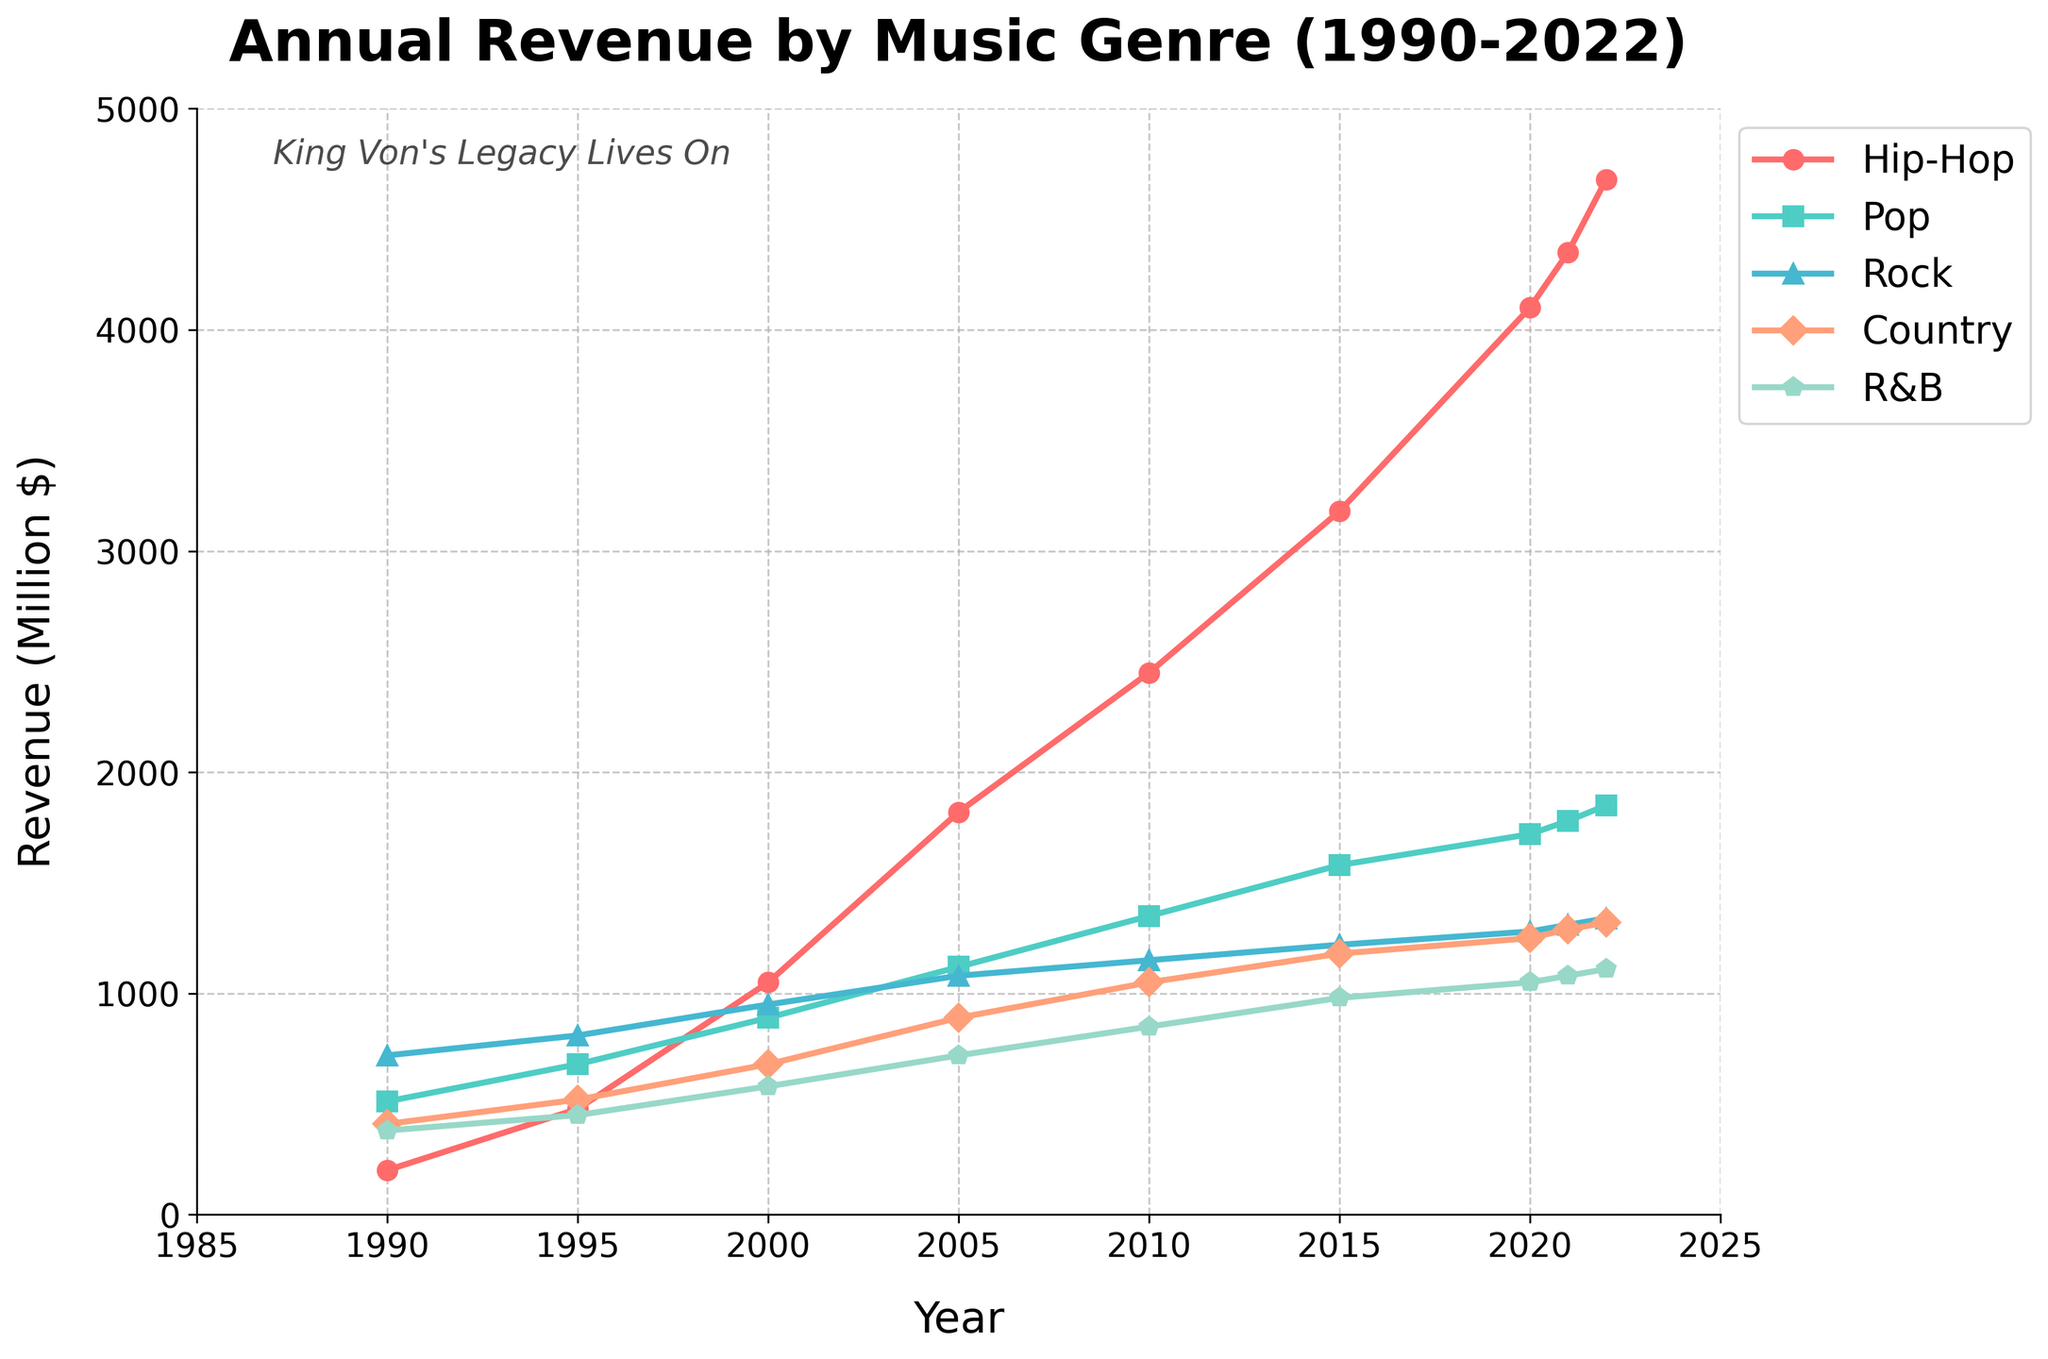Which genre had the highest revenue in 1990? Look at the y-axis values for 1990 and compare the points for all genres. Rock has the highest value at 720 million dollars.
Answer: Rock How did hip-hop revenue change from 2000 to 2010? Find the points for hip-hop in 2000 and 2010. Subtract the 2000 value (1050) from the 2010 value (2450) to get the difference.
Answer: Increased by 1400 million dollars Which genre experienced the largest revenue increase between 2010 and 2020? Calculate the revenue change for each genre by subtracting the 2010 values from the 2020 values. Hip-hop increased from 2450 to 4100 million dollars, which is an increase of 1650 million dollars, the highest among all genres.
Answer: Hip-Hop What was the pop genre's revenue in 2015 compared to 2000? Look at the y-axis values for pop in both years. The revenue in 2000 is 890 million dollars, and in 2015 it is 1580 million dollars. Subtract the 2000 revenue from the 2015 revenue (1580 - 890).
Answer: Increased by 690 million dollars Which genres had higher revenue than country music in 2022? Compare the 2022 y-axis values for all genres against the country revenue (1320). Hip-Hop (4680), Pop (1850), and Rock (1340) have higher revenues.
Answer: Hip-Hop, Pop, Rock What's the average annual revenue for R&B from 1990 to 2022? Sum the R&B revenues: 380, 450, 580, 720, 850, 980, 1050, 1080, 1110 = 7200. Divide by the number of years (9).
Answer: 800 million dollars Which genre's revenue grew the most consistently over the years from 1990 to 2022? Compare the trend lines for each genre. Hip-Hop shows a steady and significant growth without drops, implying consistent growth.
Answer: Hip-Hop What was the total revenue for pop music in the year 2021? Identify the value for pop music in 2021 from the chart, which is 1780 million dollars.
Answer: 1780 million dollars How does the 2022 revenue for rock compare to R&B? Compare the values on the y-axis for rock (1340) and R&B (1110) in 2022.
Answer: Rock has 230 million dollars more than R&B Between 1990 and 2005, which genre had the smallest increase in revenue? Calculate the difference in revenue for each genre from 1990 to 2005. Country (890 - 410 = 480) has the smallest increase.
Answer: Country 